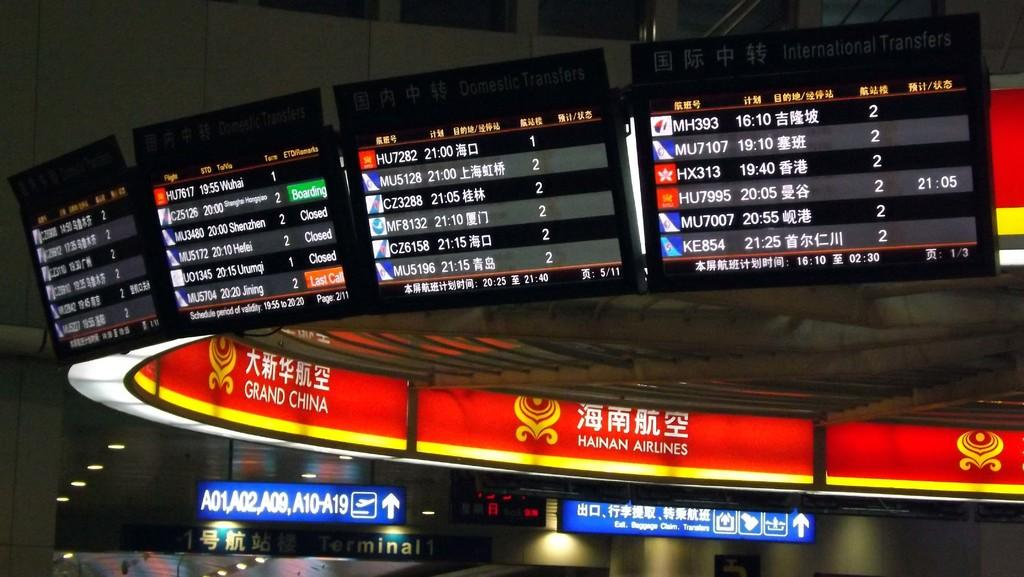<image>
Write a terse but informative summary of the picture. An electronic board at the top of an airline terminal showing what planes are in what gates written all in Chinese lettering. 